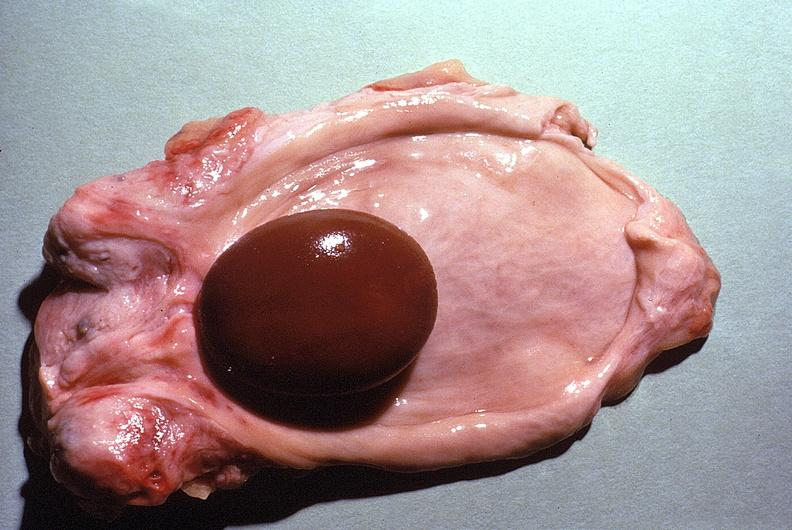what does this image show?
Answer the question using a single word or phrase. Urinary bladder 